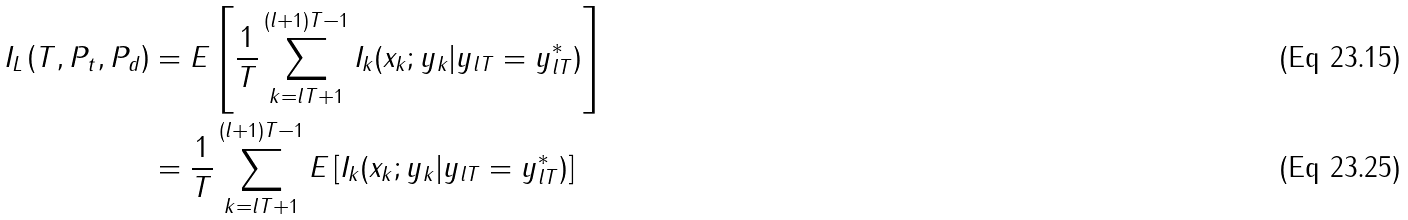Convert formula to latex. <formula><loc_0><loc_0><loc_500><loc_500>I _ { L } \left ( T , P _ { t } , P _ { d } \right ) & = E \left [ \frac { 1 } { T } \sum _ { k = l T + 1 } ^ { ( l + 1 ) T - 1 } I _ { k } ( x _ { k } ; y _ { k } | y _ { l T } = y _ { l T } ^ { * } ) \right ] \\ & = \frac { 1 } { T } \sum _ { k = l T + 1 } ^ { ( l + 1 ) T - 1 } E \left [ I _ { k } ( x _ { k } ; y _ { k } | y _ { l T } = y _ { l T } ^ { * } ) \right ]</formula> 